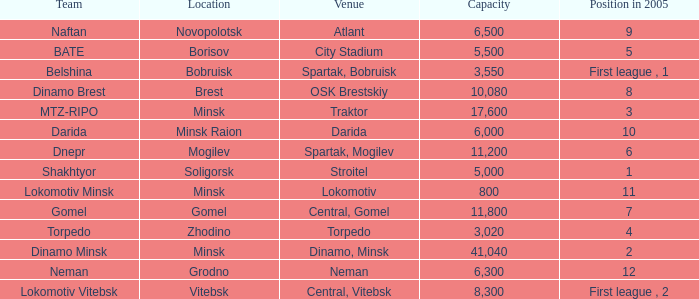Can you tell me the highest Capacity that has the Team of torpedo? 3020.0. 